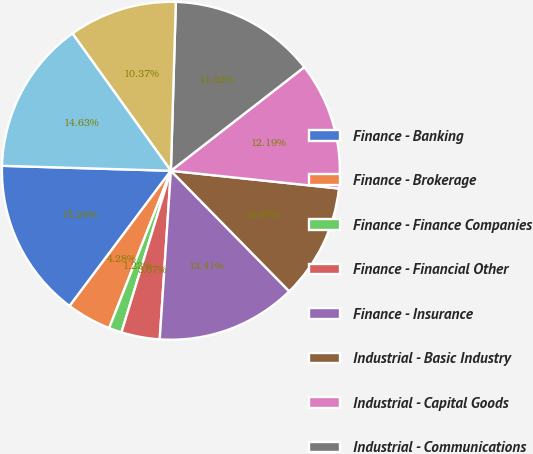Convert chart to OTSL. <chart><loc_0><loc_0><loc_500><loc_500><pie_chart><fcel>Finance - Banking<fcel>Finance - Brokerage<fcel>Finance - Finance Companies<fcel>Finance - Financial Other<fcel>Finance - Insurance<fcel>Industrial - Basic Industry<fcel>Industrial - Capital Goods<fcel>Industrial - Communications<fcel>Industrial - Consumer Cyclical<fcel>Industrial - Consumer<nl><fcel>15.24%<fcel>4.28%<fcel>1.23%<fcel>3.67%<fcel>13.41%<fcel>10.97%<fcel>12.19%<fcel>14.02%<fcel>10.37%<fcel>14.63%<nl></chart> 